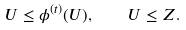Convert formula to latex. <formula><loc_0><loc_0><loc_500><loc_500>U \leq \phi ^ { ( t ) } ( U ) , \quad U \leq Z .</formula> 